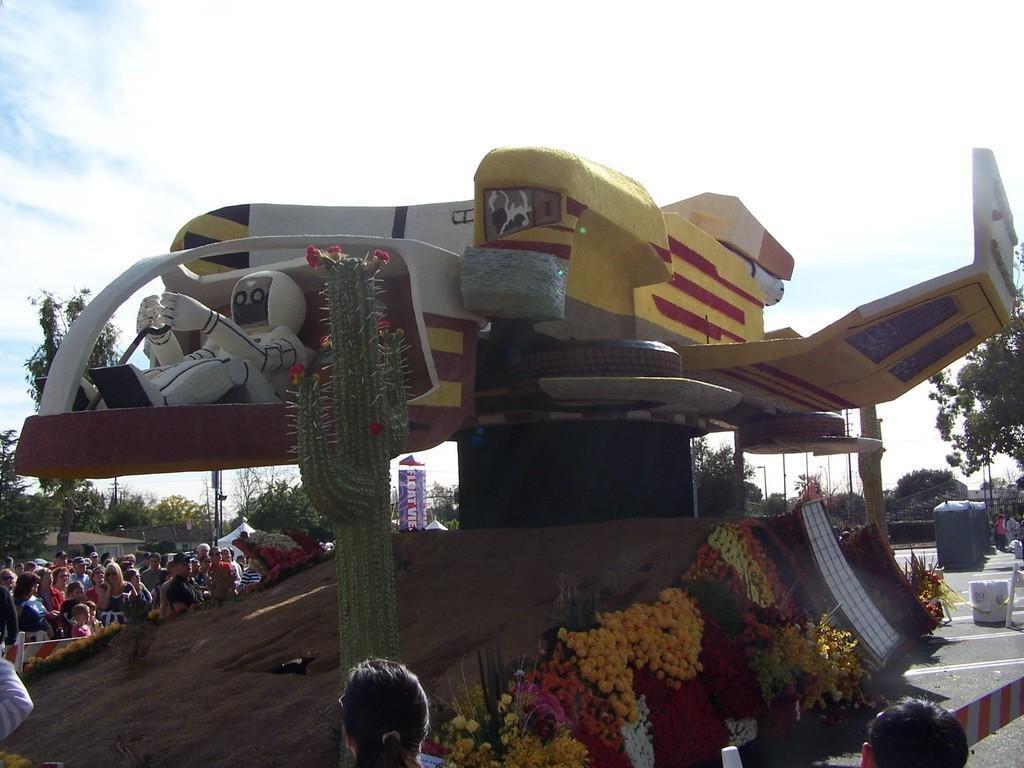How would you summarize this image in a sentence or two? In the center of the image we can see fun ride. On the right side of the image we can see persons, flowers and trees. On the left side of the image we can see persons and trees. In the background there are clouds and sky. 